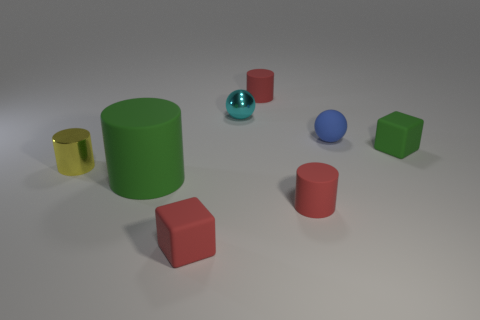Are there an equal number of metallic cylinders that are on the right side of the small blue matte ball and small matte blocks to the left of the small red matte block?
Make the answer very short. Yes. There is a tiny metallic thing that is in front of the blue rubber object; is its shape the same as the cyan metallic thing?
Your answer should be very brief. No. Do the cyan object and the big thing have the same shape?
Your response must be concise. No. How many matte objects are yellow cylinders or blue things?
Offer a very short reply. 1. What is the material of the thing that is the same color as the big rubber cylinder?
Your response must be concise. Rubber. Is the green cube the same size as the red rubber cube?
Offer a terse response. Yes. What number of objects are small red cylinders or tiny shiny things that are in front of the small metal sphere?
Keep it short and to the point. 3. What material is the yellow cylinder that is the same size as the blue ball?
Ensure brevity in your answer.  Metal. What material is the red thing that is both in front of the tiny blue rubber thing and to the right of the red rubber cube?
Your answer should be very brief. Rubber. There is a small cube that is on the left side of the blue rubber object; are there any blocks behind it?
Ensure brevity in your answer.  Yes. 